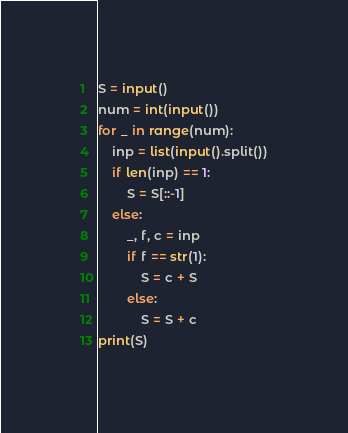<code> <loc_0><loc_0><loc_500><loc_500><_Python_>S = input()
num = int(input())
for _ in range(num):
    inp = list(input().split())
    if len(inp) == 1:
        S = S[::-1]
    else:
        _, f, c = inp
        if f == str(1):
            S = c + S
        else:
            S = S + c 
print(S)</code> 